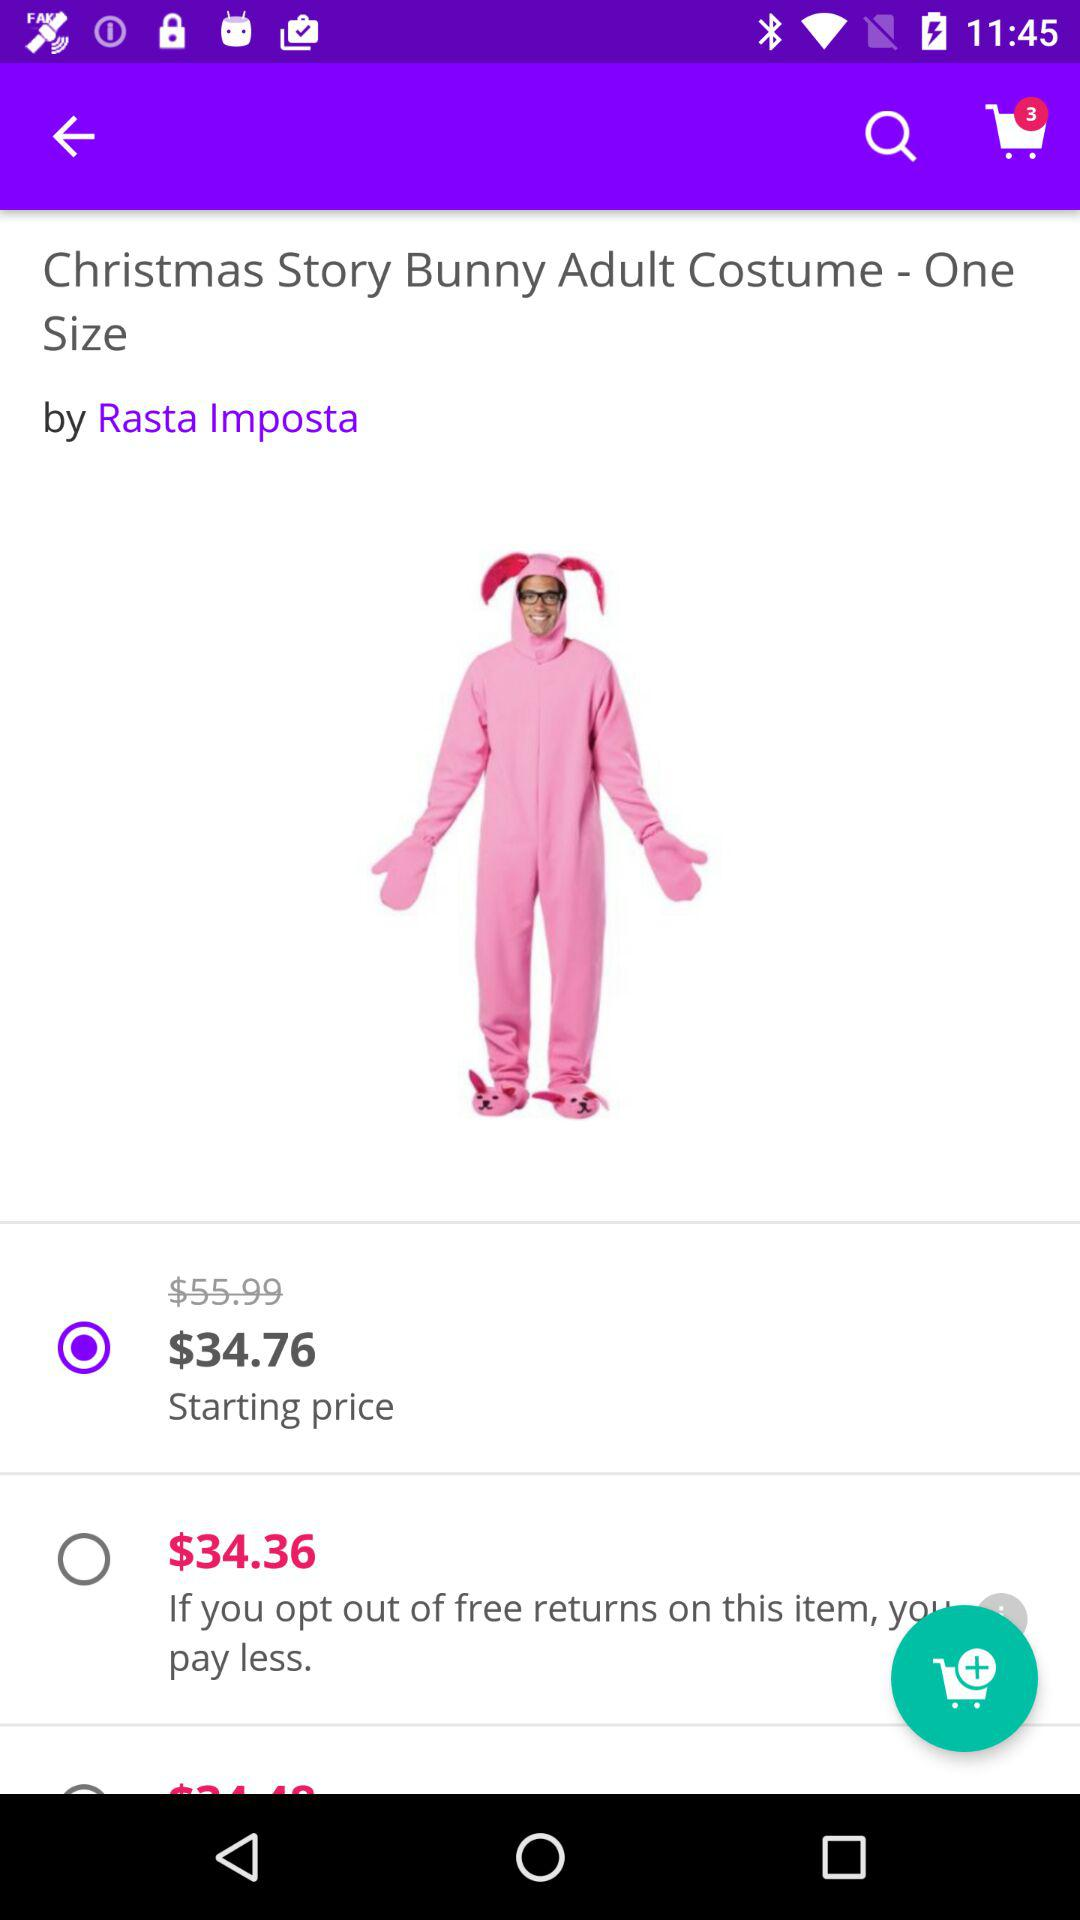What is the starting price of the costume? The starting price is $34.76. 